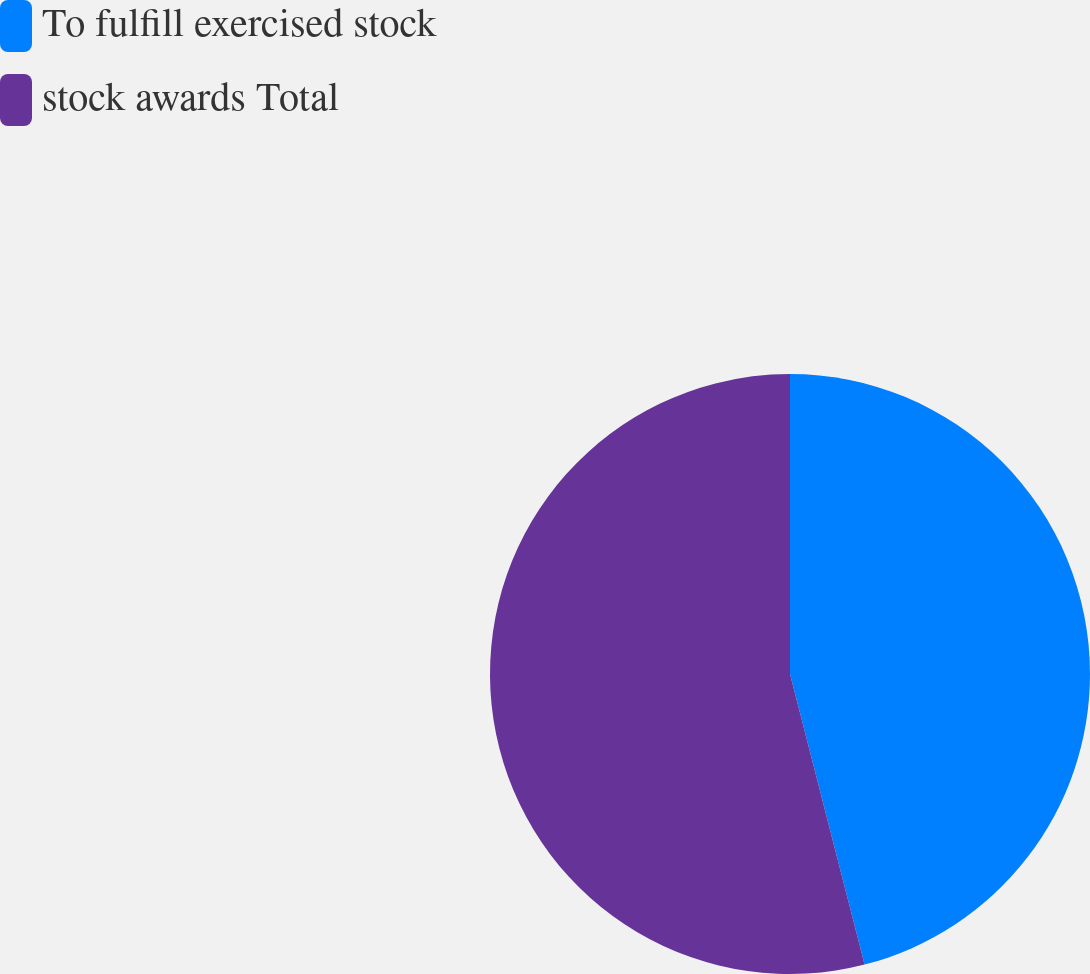<chart> <loc_0><loc_0><loc_500><loc_500><pie_chart><fcel>To fulfill exercised stock<fcel>stock awards Total<nl><fcel>46.0%<fcel>54.0%<nl></chart> 